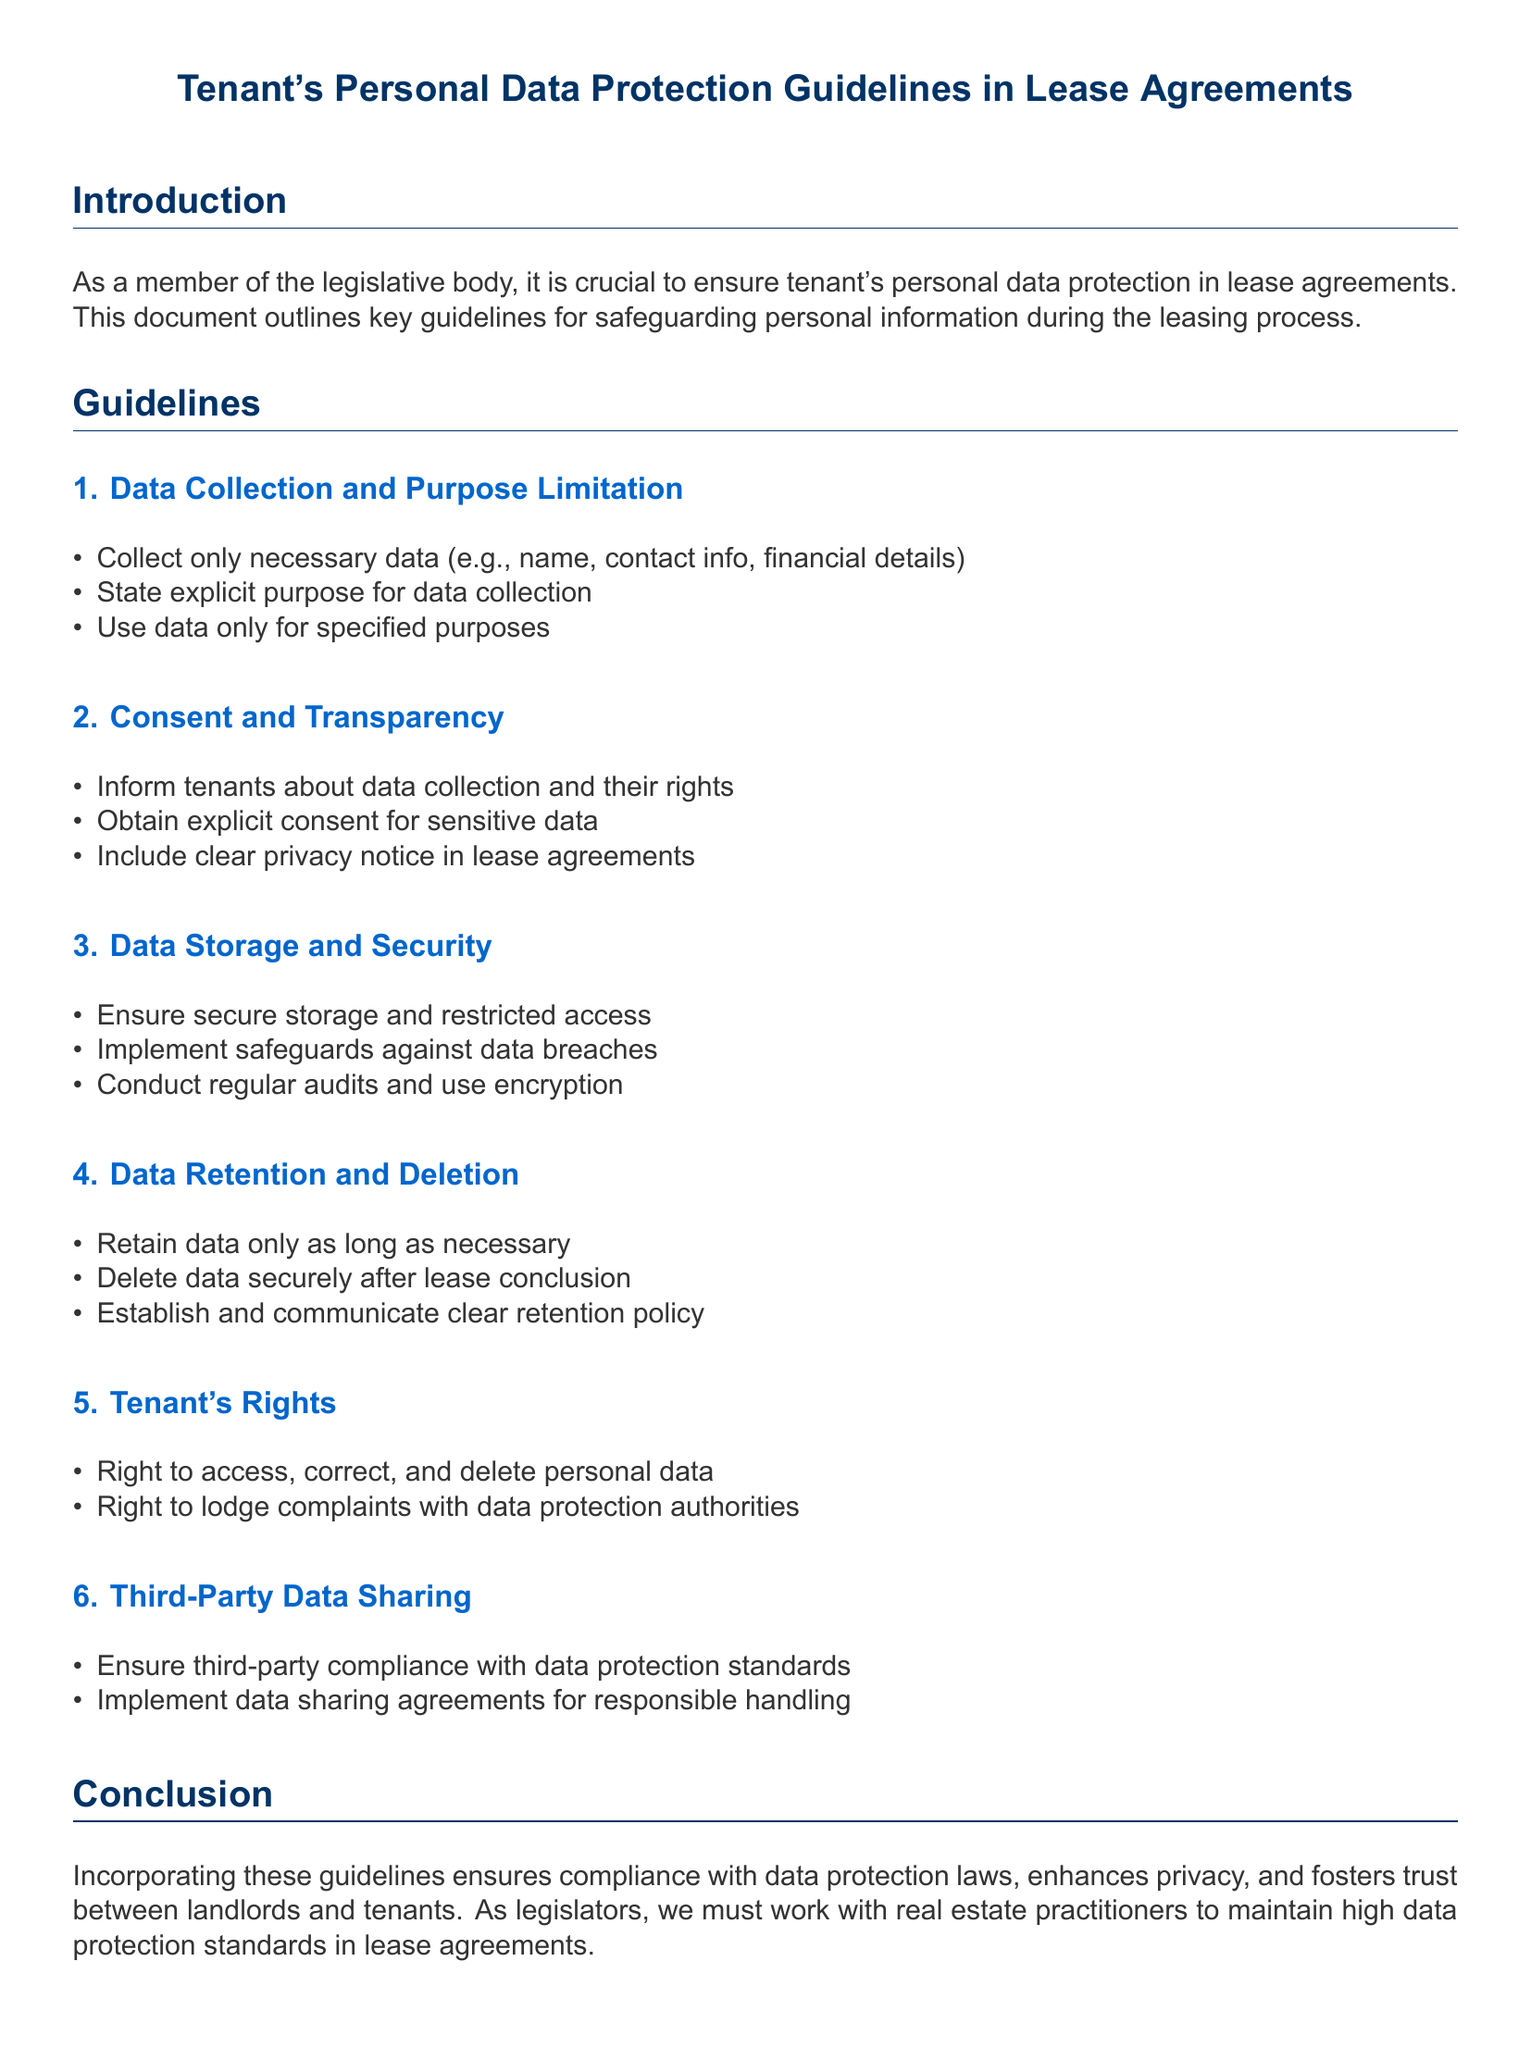What is the document's title? The document's title appears at the beginning as "Tenant's Personal Data Protection Guidelines in Lease Agreements."
Answer: Tenant's Personal Data Protection Guidelines in Lease Agreements What is the first guideline? The first guideline is about data collection and purpose limitation, stating the importance of collecting only necessary data.
Answer: Data Collection and Purpose Limitation What rights do tenants have regarding their personal data? The document outlines the rights of tenants, including the right to access, correct, and delete personal data.
Answer: Right to access, correct, and delete personal data How long should data be retained? The document mentions that data should be retained only as long as necessary.
Answer: Only as long as necessary What should happen to data after the lease concludes? According to the guidelines, data must be deleted securely after the lease conclusion.
Answer: Deleted securely after lease conclusion What action must be taken before sharing data with third parties? The document states that compliance with data protection standards must be ensured for third-party data sharing.
Answer: Ensure third-party compliance What must landlords include regarding privacy? Landlords are required to include a clear privacy notice in lease agreements.
Answer: Clear privacy notice How often should audits be conducted? The guidelines mention conducting regular audits for data security.
Answer: Regular audits What is a purpose of data collection mentioned? One of the purposes of data collection stated could be financial details.
Answer: Financial details 